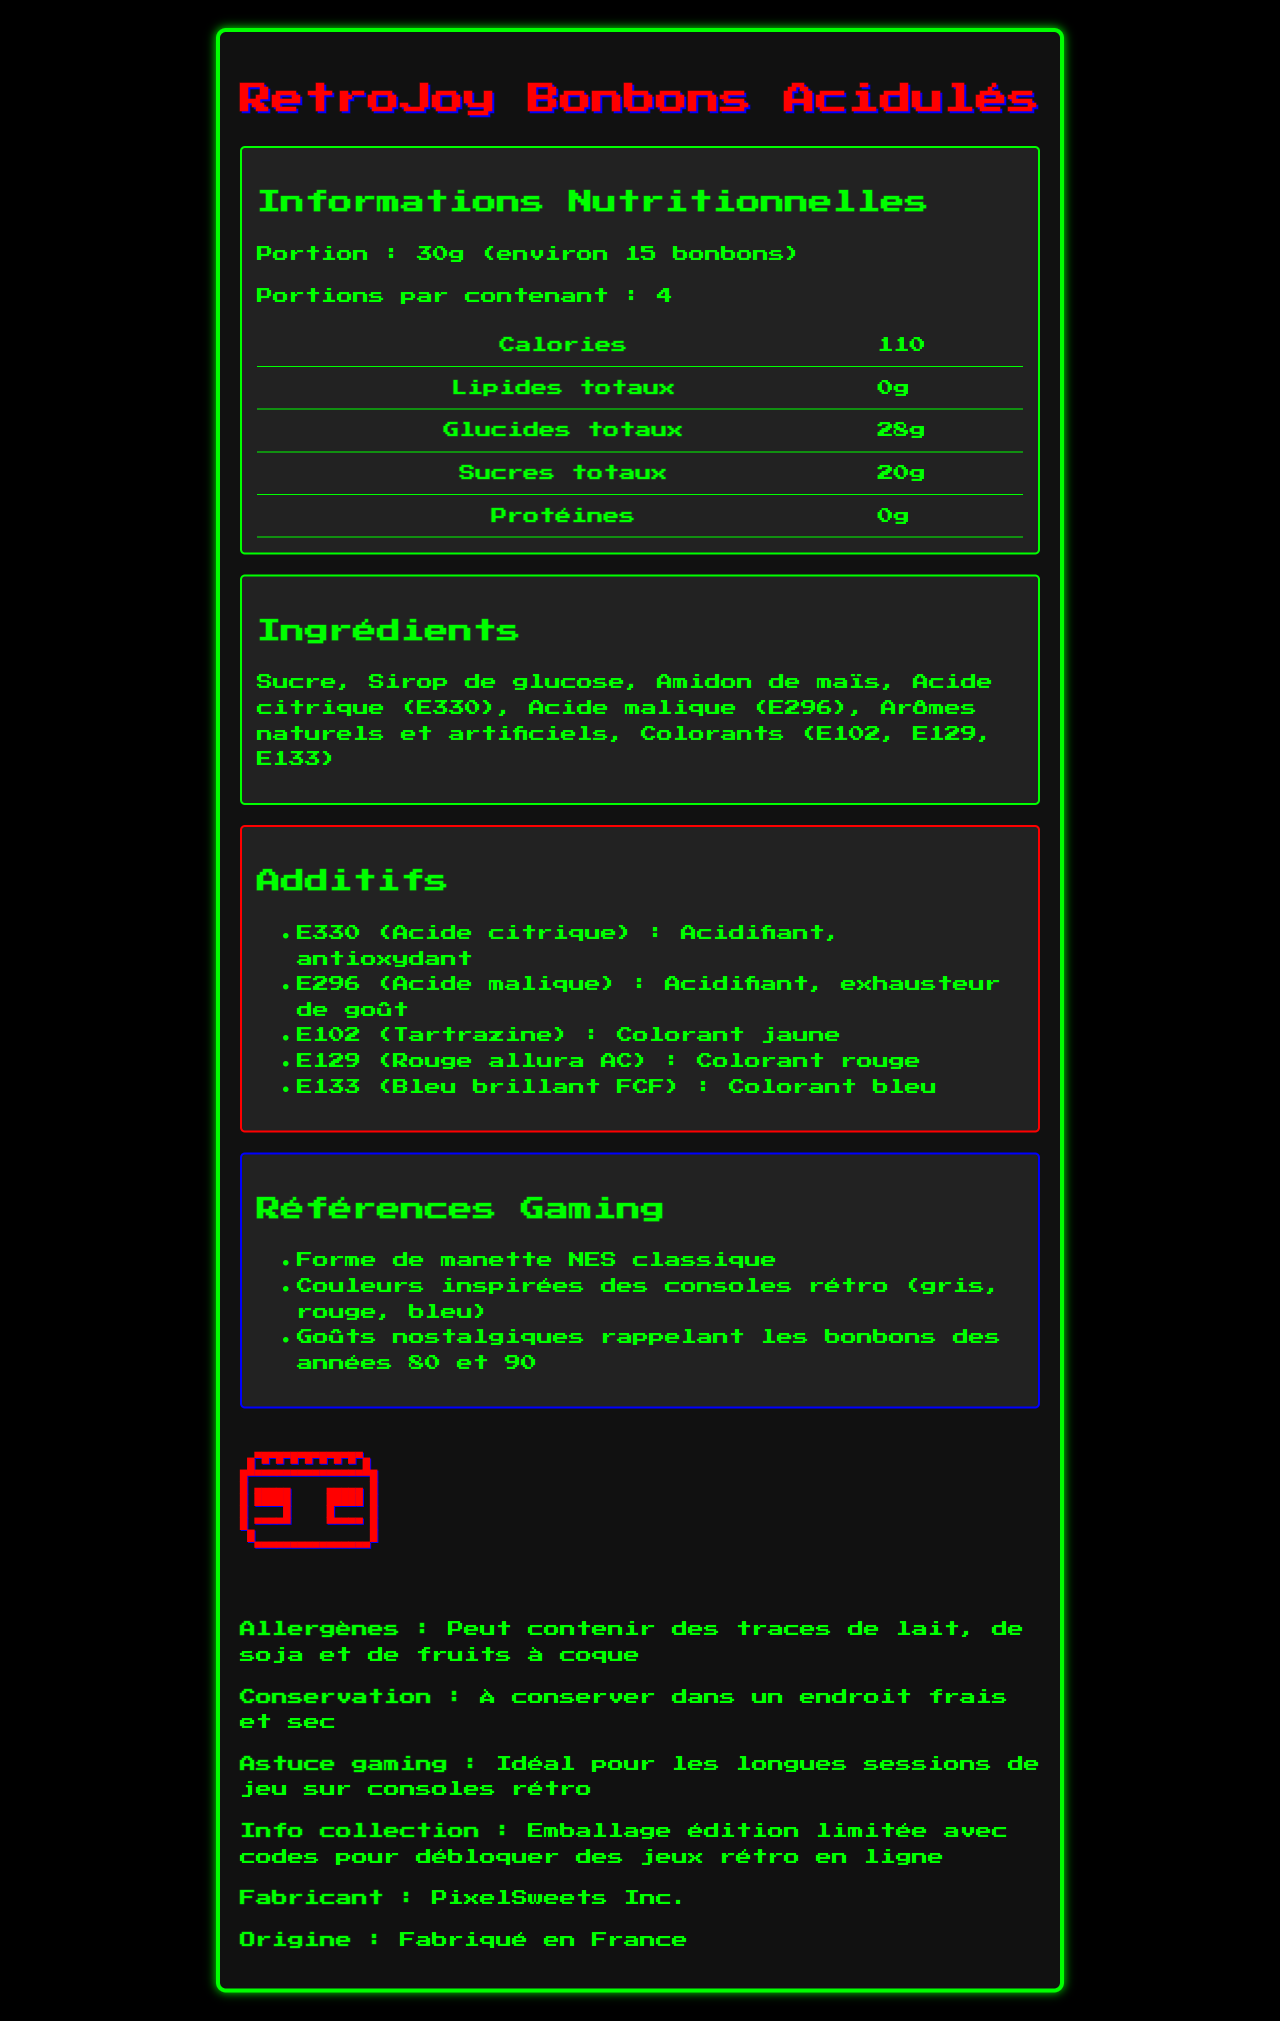what is the product name? The product name is prominently displayed at the top of the document.
Answer: RetroJoy Bonbons Acidulés what is the serving size of the RetroJoy Bonbons Acidulés? The serving size is specified in the nutrition facts section.
Answer: 30g (environ 15 bonbons) how many calories are there per serving? The number of calories per serving is listed in the nutrition facts section.
Answer: 110 what are the main ingredients of the RetroJoy Bonbons Acidulés? The main ingredients are listed in the ingredients section.
Answer: Sucre, Sirop de glucose, Amidon de maïs, Acide citrique (E330), Acide malique (E296), Arômes naturels et artificiels, Colorants (E102, E129, E133) List three gaming references mentioned in the document. These references are found in the gaming references section.
Answer: Forme de manette NES classique, Couleurs inspirées des consoles rétro (gris, rouge, bleu), Goûts nostalgiques rappelant les bonbons des années 80 et 90 which additives are used in the RetroJoy Bonbons Acidulés? A. Acide citrique, Acide malique B. E330, E296, E102 C. E330, E296, E102, E129, E133 D. Sucre, Sirop de glucose, Amidon de maïs The additives section lists E330, E296, E102, E129, and E133.
Answer: C what allergens might be present in the RetroJoy Bonbons Acidulés? A. Lait, Soja, Fruits de mer B. Œufs, Poisson, Fruits de mer C. Lait, Soja, Fruits à coque D. Blé, Lait, Œufs The allergens section specifies 'Peut contenir des traces de lait, de soja et de fruits à coque.'
Answer: C is there any dietary fiber in the RetroJoy Bonbons Acidulés? The nutrition facts section indicates that there is 0g of dietary fiber.
Answer: No are the RetroJoy Bonbons Acidulés suitable for a vegan diet? The document does not provide enough information to determine if the bonbons are vegan. There is a mention of potential traces of milk, which could be an issue for vegans.
Answer: Cannot be determined summarize the main information about the RetroJoy Bonbons Acidulés. This summary encapsulates all major sections: nutritional information, ingredients, additives, gaming references, allergens, conservation advice, gaming tips, collectible info, manufacturer details, and country of origin.
Answer: The RetroJoy Bonbons Acidulés are retro-themed sour candies shaped like classic NES controllers, inspired by retro gaming colors and flavors from the 80s and 90s. Each serving is 30g with 110 calories, containing sugars and several food additives like E330 and E296. The product might contain allergens such as milk, soy, and nuts and is manufactured by PixelSweets Inc. in France. It also has a limited edition packaging that includes codes for unlocking retro games online. what is the function of the additive E330? The function of E330 (Acide citrique) is mentioned in the additives section.
Answer: Acidifiant, antioxydant is there any protein in a serving of RetroJoy Bonbons Acidulés? The nutrition facts section shows that there is 0g of protein.
Answer: No what is the country of origin of the RetroJoy Bonbons Acidulés? The country of origin is specified at the bottom of the document.
Answer: Fabriqué en France what specific nostalgic gaming elements are referenced in the candy packaging? The gaming references section lists these nostalgic gaming elements.
Answer: Forme de manette NES classique, Couleurs inspirées des consoles rétro (gris, rouge, bleu), Goûts nostalgiques rappelant les bonbons des années 80 et 90 Are the RetroJoy Bonbons Acidulés free of artificial colors? The ingredients list includes artificial colorants (E102, E129, E133).
Answer: No who is the manufacturer of these bonbons? The manufacturer is mentioned towards the end of the document.
Answer: PixelSweets Inc. 